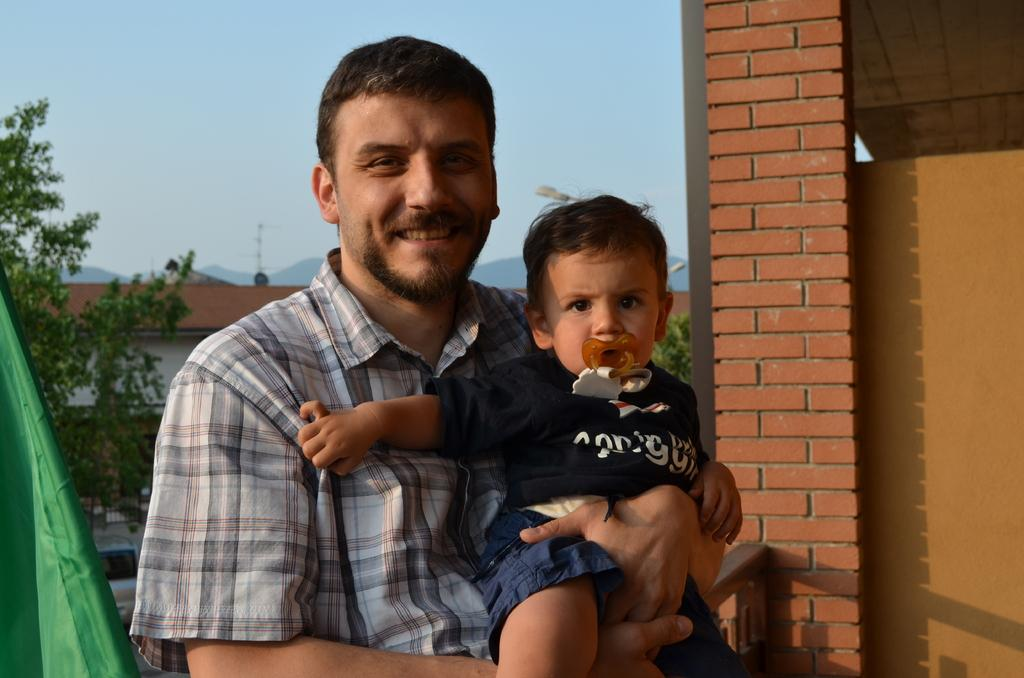Who is present in the image? There is a man in the image. What is the man doing in the image? The man is smiling and holding a baby. What can be seen in the background of the image? There are trees and buildings in the background of the image. What type of structure is visible in the image? There is a brick wall in the image. How many dimes are visible on the ground in the image? There are no dimes visible on the ground in the image. What type of animals can be seen at the zoo in the image? There is no zoo present in the image; it features a man holding a baby with trees and buildings in the background. 